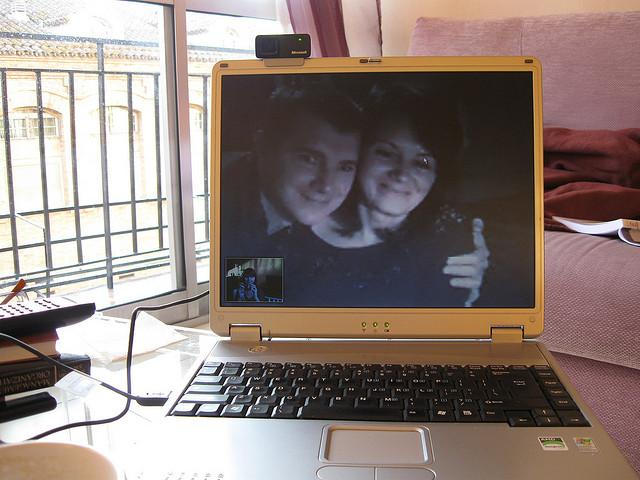Who is using this laptop? woman 